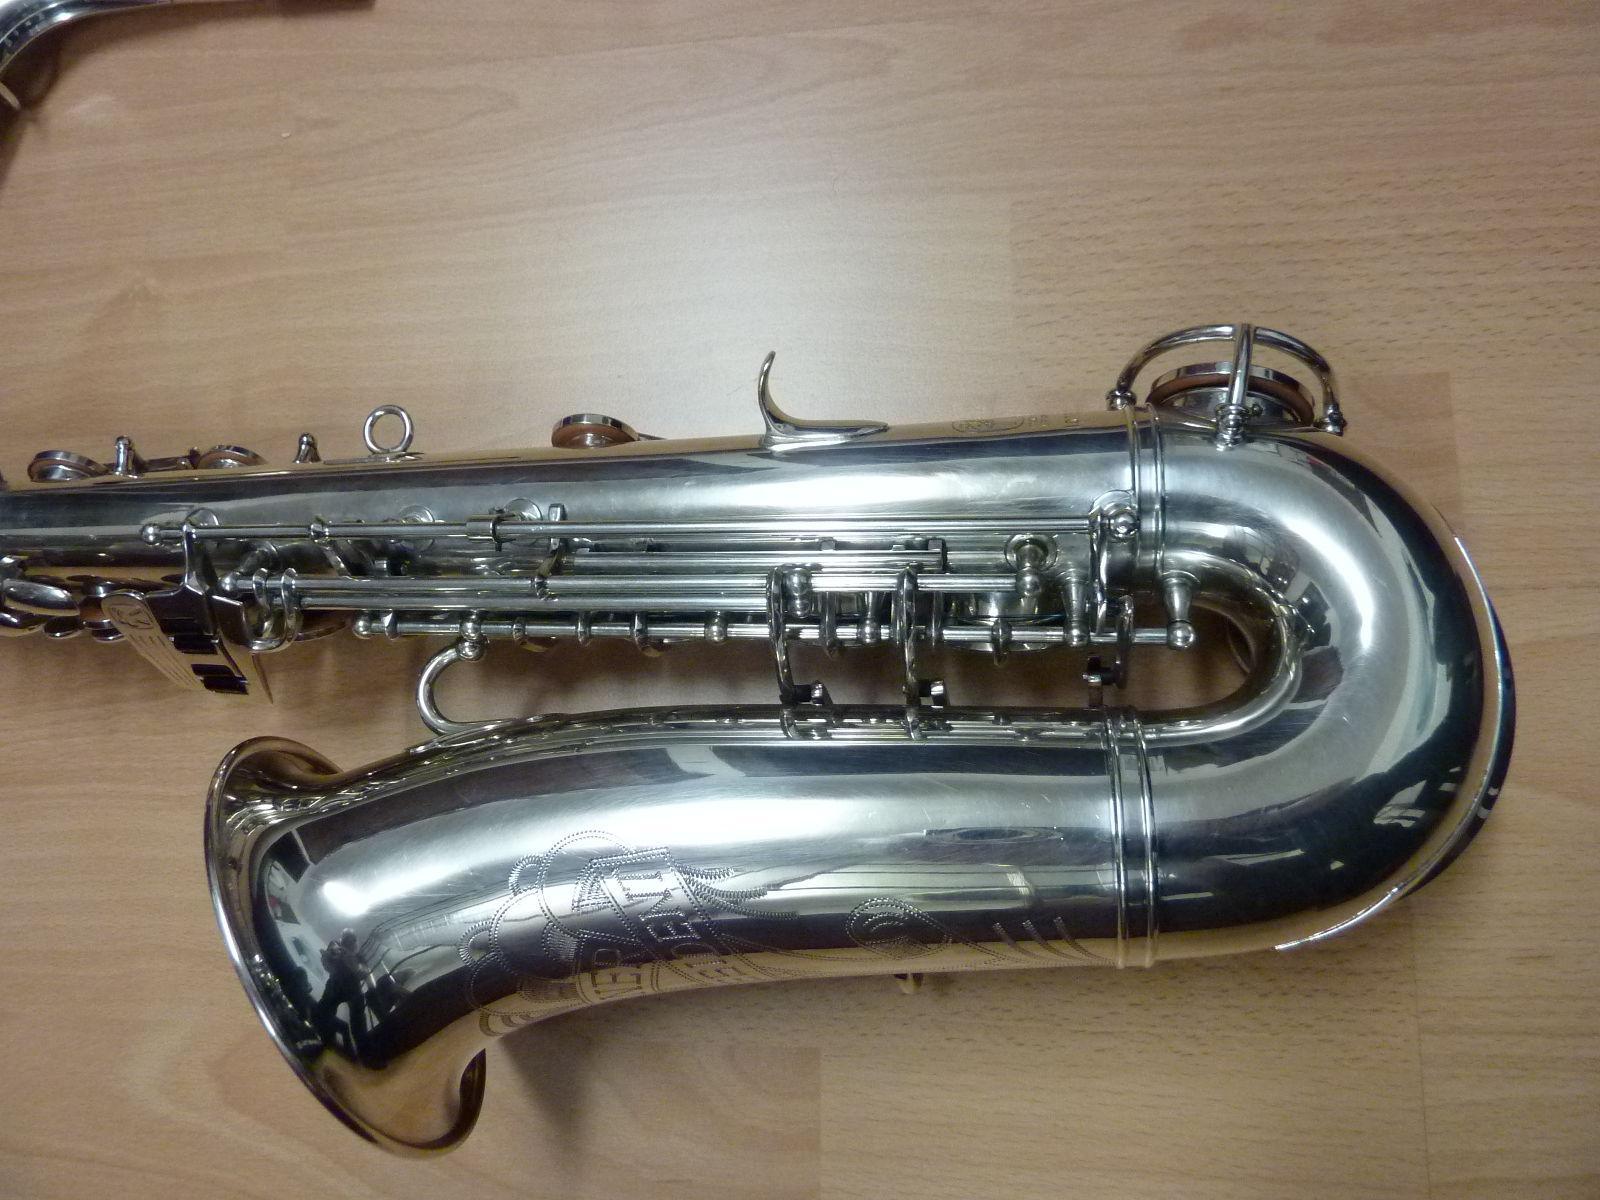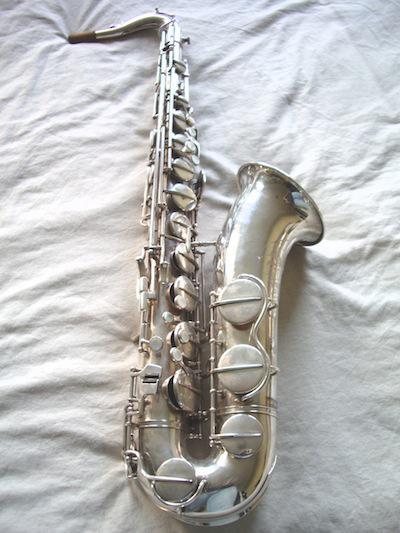The first image is the image on the left, the second image is the image on the right. Evaluate the accuracy of this statement regarding the images: "In one image, a full length saxophone is lying flat on a cloth, while a second image shows only the lower section of a silver saxophone.". Is it true? Answer yes or no. Yes. The first image is the image on the left, the second image is the image on the right. Given the left and right images, does the statement "The left sax is gold and the right one is silver." hold true? Answer yes or no. No. The first image is the image on the left, the second image is the image on the right. Given the left and right images, does the statement "A total of two saxophones are shown, and one saxophone is displayed on some type of red fabric." hold true? Answer yes or no. No. The first image is the image on the left, the second image is the image on the right. Evaluate the accuracy of this statement regarding the images: "An image shows a silver saxophone in an open case lined with crushed red velvet.". Is it true? Answer yes or no. No. 